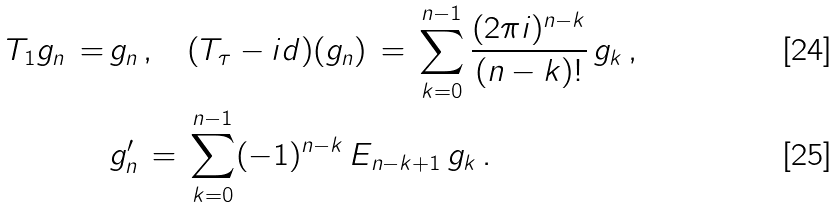Convert formula to latex. <formula><loc_0><loc_0><loc_500><loc_500>T _ { 1 } g _ { n } \, = \, & g _ { n } \, , \quad ( T _ { \tau } - i d ) ( g _ { n } ) \, = \, \sum _ { k = 0 } ^ { n - 1 } \frac { ( 2 \pi i ) ^ { n - k } } { ( n - k ) ! } \, g _ { k } \, , \\ & g _ { n } ^ { \prime } \, = \, \sum _ { k = 0 } ^ { n - 1 } ( - 1 ) ^ { n - k } \, E _ { n - k + 1 } \, g _ { k } \, .</formula> 